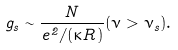<formula> <loc_0><loc_0><loc_500><loc_500>g _ { s } \sim \frac { N } { e ^ { 2 } / ( \kappa R ) } ( \nu > \nu _ { s } ) .</formula> 